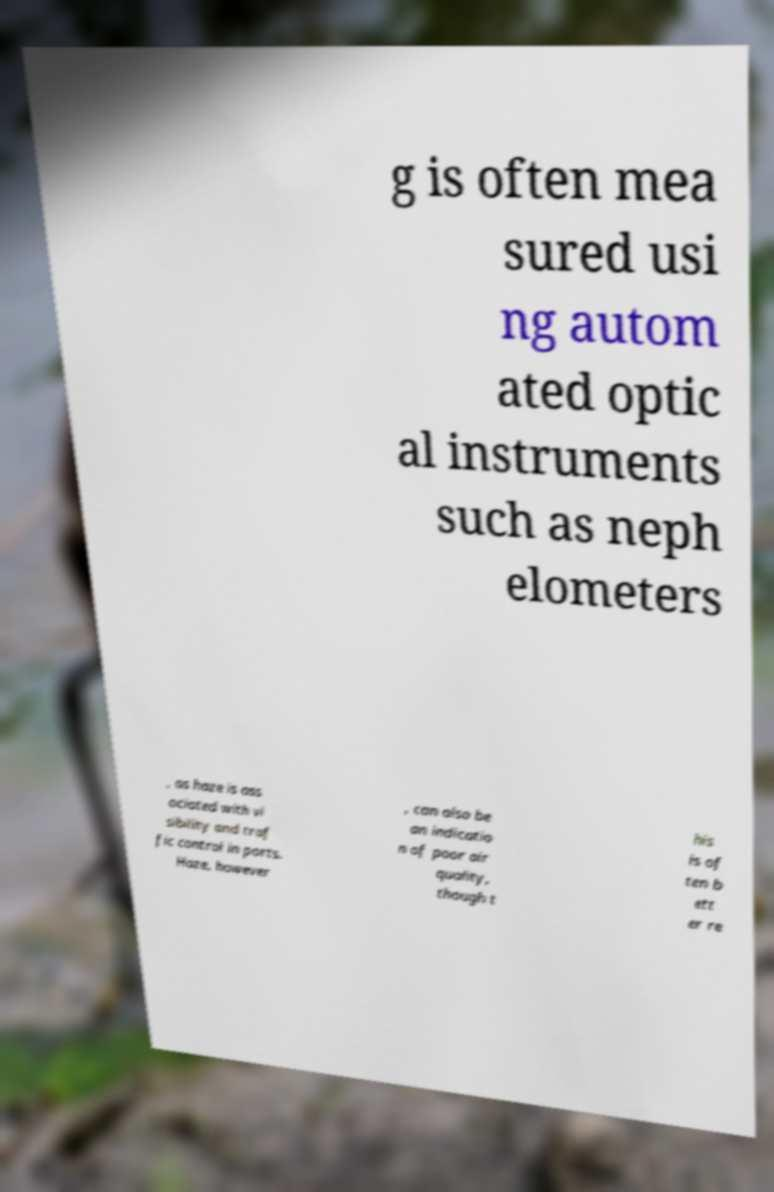For documentation purposes, I need the text within this image transcribed. Could you provide that? g is often mea sured usi ng autom ated optic al instruments such as neph elometers , as haze is ass ociated with vi sibility and traf fic control in ports. Haze, however , can also be an indicatio n of poor air quality, though t his is of ten b ett er re 